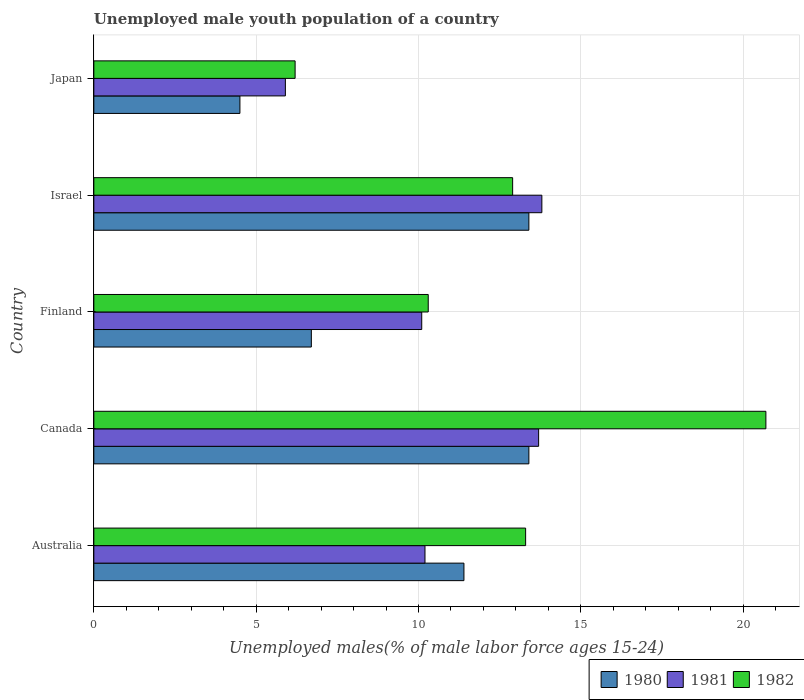Are the number of bars on each tick of the Y-axis equal?
Give a very brief answer. Yes. How many bars are there on the 5th tick from the top?
Your answer should be compact. 3. What is the label of the 5th group of bars from the top?
Make the answer very short. Australia. In how many cases, is the number of bars for a given country not equal to the number of legend labels?
Provide a short and direct response. 0. What is the percentage of unemployed male youth population in 1982 in Japan?
Your response must be concise. 6.2. Across all countries, what is the maximum percentage of unemployed male youth population in 1980?
Provide a succinct answer. 13.4. Across all countries, what is the minimum percentage of unemployed male youth population in 1982?
Make the answer very short. 6.2. In which country was the percentage of unemployed male youth population in 1980 maximum?
Your answer should be compact. Canada. What is the total percentage of unemployed male youth population in 1981 in the graph?
Provide a short and direct response. 53.7. What is the difference between the percentage of unemployed male youth population in 1981 in Finland and that in Israel?
Give a very brief answer. -3.7. What is the difference between the percentage of unemployed male youth population in 1981 in Japan and the percentage of unemployed male youth population in 1980 in Australia?
Your response must be concise. -5.5. What is the average percentage of unemployed male youth population in 1981 per country?
Provide a succinct answer. 10.74. What is the difference between the percentage of unemployed male youth population in 1981 and percentage of unemployed male youth population in 1982 in Israel?
Ensure brevity in your answer.  0.9. What is the ratio of the percentage of unemployed male youth population in 1981 in Australia to that in Canada?
Your answer should be very brief. 0.74. Is the difference between the percentage of unemployed male youth population in 1981 in Canada and Japan greater than the difference between the percentage of unemployed male youth population in 1982 in Canada and Japan?
Give a very brief answer. No. What is the difference between the highest and the second highest percentage of unemployed male youth population in 1981?
Give a very brief answer. 0.1. What is the difference between the highest and the lowest percentage of unemployed male youth population in 1982?
Your answer should be compact. 14.5. In how many countries, is the percentage of unemployed male youth population in 1982 greater than the average percentage of unemployed male youth population in 1982 taken over all countries?
Your answer should be very brief. 3. Is the sum of the percentage of unemployed male youth population in 1982 in Australia and Finland greater than the maximum percentage of unemployed male youth population in 1980 across all countries?
Your answer should be compact. Yes. What does the 2nd bar from the top in Japan represents?
Offer a terse response. 1981. How many bars are there?
Make the answer very short. 15. Are all the bars in the graph horizontal?
Ensure brevity in your answer.  Yes. Does the graph contain any zero values?
Offer a terse response. No. Does the graph contain grids?
Your response must be concise. Yes. What is the title of the graph?
Your response must be concise. Unemployed male youth population of a country. What is the label or title of the X-axis?
Your response must be concise. Unemployed males(% of male labor force ages 15-24). What is the Unemployed males(% of male labor force ages 15-24) in 1980 in Australia?
Your answer should be compact. 11.4. What is the Unemployed males(% of male labor force ages 15-24) in 1981 in Australia?
Make the answer very short. 10.2. What is the Unemployed males(% of male labor force ages 15-24) in 1982 in Australia?
Offer a very short reply. 13.3. What is the Unemployed males(% of male labor force ages 15-24) in 1980 in Canada?
Your answer should be compact. 13.4. What is the Unemployed males(% of male labor force ages 15-24) of 1981 in Canada?
Give a very brief answer. 13.7. What is the Unemployed males(% of male labor force ages 15-24) of 1982 in Canada?
Keep it short and to the point. 20.7. What is the Unemployed males(% of male labor force ages 15-24) in 1980 in Finland?
Keep it short and to the point. 6.7. What is the Unemployed males(% of male labor force ages 15-24) in 1981 in Finland?
Offer a terse response. 10.1. What is the Unemployed males(% of male labor force ages 15-24) in 1982 in Finland?
Offer a terse response. 10.3. What is the Unemployed males(% of male labor force ages 15-24) of 1980 in Israel?
Provide a succinct answer. 13.4. What is the Unemployed males(% of male labor force ages 15-24) in 1981 in Israel?
Your response must be concise. 13.8. What is the Unemployed males(% of male labor force ages 15-24) in 1982 in Israel?
Ensure brevity in your answer.  12.9. What is the Unemployed males(% of male labor force ages 15-24) in 1980 in Japan?
Offer a terse response. 4.5. What is the Unemployed males(% of male labor force ages 15-24) in 1981 in Japan?
Offer a very short reply. 5.9. What is the Unemployed males(% of male labor force ages 15-24) of 1982 in Japan?
Provide a succinct answer. 6.2. Across all countries, what is the maximum Unemployed males(% of male labor force ages 15-24) of 1980?
Give a very brief answer. 13.4. Across all countries, what is the maximum Unemployed males(% of male labor force ages 15-24) of 1981?
Keep it short and to the point. 13.8. Across all countries, what is the maximum Unemployed males(% of male labor force ages 15-24) in 1982?
Your answer should be compact. 20.7. Across all countries, what is the minimum Unemployed males(% of male labor force ages 15-24) in 1980?
Provide a succinct answer. 4.5. Across all countries, what is the minimum Unemployed males(% of male labor force ages 15-24) in 1981?
Offer a very short reply. 5.9. Across all countries, what is the minimum Unemployed males(% of male labor force ages 15-24) of 1982?
Provide a succinct answer. 6.2. What is the total Unemployed males(% of male labor force ages 15-24) in 1980 in the graph?
Your answer should be compact. 49.4. What is the total Unemployed males(% of male labor force ages 15-24) in 1981 in the graph?
Your answer should be very brief. 53.7. What is the total Unemployed males(% of male labor force ages 15-24) of 1982 in the graph?
Keep it short and to the point. 63.4. What is the difference between the Unemployed males(% of male labor force ages 15-24) of 1980 in Australia and that in Canada?
Your response must be concise. -2. What is the difference between the Unemployed males(% of male labor force ages 15-24) in 1981 in Australia and that in Canada?
Provide a short and direct response. -3.5. What is the difference between the Unemployed males(% of male labor force ages 15-24) in 1982 in Australia and that in Canada?
Offer a very short reply. -7.4. What is the difference between the Unemployed males(% of male labor force ages 15-24) in 1980 in Australia and that in Finland?
Your answer should be very brief. 4.7. What is the difference between the Unemployed males(% of male labor force ages 15-24) of 1981 in Australia and that in Finland?
Provide a short and direct response. 0.1. What is the difference between the Unemployed males(% of male labor force ages 15-24) in 1982 in Australia and that in Finland?
Keep it short and to the point. 3. What is the difference between the Unemployed males(% of male labor force ages 15-24) of 1981 in Australia and that in Israel?
Offer a terse response. -3.6. What is the difference between the Unemployed males(% of male labor force ages 15-24) of 1982 in Australia and that in Israel?
Keep it short and to the point. 0.4. What is the difference between the Unemployed males(% of male labor force ages 15-24) of 1980 in Australia and that in Japan?
Offer a very short reply. 6.9. What is the difference between the Unemployed males(% of male labor force ages 15-24) of 1981 in Australia and that in Japan?
Your answer should be very brief. 4.3. What is the difference between the Unemployed males(% of male labor force ages 15-24) of 1980 in Canada and that in Finland?
Offer a very short reply. 6.7. What is the difference between the Unemployed males(% of male labor force ages 15-24) in 1981 in Canada and that in Finland?
Make the answer very short. 3.6. What is the difference between the Unemployed males(% of male labor force ages 15-24) in 1980 in Canada and that in Israel?
Provide a succinct answer. 0. What is the difference between the Unemployed males(% of male labor force ages 15-24) of 1981 in Canada and that in Israel?
Ensure brevity in your answer.  -0.1. What is the difference between the Unemployed males(% of male labor force ages 15-24) of 1981 in Canada and that in Japan?
Your answer should be very brief. 7.8. What is the difference between the Unemployed males(% of male labor force ages 15-24) of 1982 in Canada and that in Japan?
Ensure brevity in your answer.  14.5. What is the difference between the Unemployed males(% of male labor force ages 15-24) in 1980 in Finland and that in Israel?
Provide a short and direct response. -6.7. What is the difference between the Unemployed males(% of male labor force ages 15-24) in 1981 in Finland and that in Israel?
Give a very brief answer. -3.7. What is the difference between the Unemployed males(% of male labor force ages 15-24) in 1982 in Finland and that in Israel?
Provide a succinct answer. -2.6. What is the difference between the Unemployed males(% of male labor force ages 15-24) in 1981 in Finland and that in Japan?
Make the answer very short. 4.2. What is the difference between the Unemployed males(% of male labor force ages 15-24) in 1982 in Finland and that in Japan?
Your answer should be very brief. 4.1. What is the difference between the Unemployed males(% of male labor force ages 15-24) of 1980 in Israel and that in Japan?
Make the answer very short. 8.9. What is the difference between the Unemployed males(% of male labor force ages 15-24) in 1981 in Israel and that in Japan?
Make the answer very short. 7.9. What is the difference between the Unemployed males(% of male labor force ages 15-24) in 1982 in Israel and that in Japan?
Provide a short and direct response. 6.7. What is the difference between the Unemployed males(% of male labor force ages 15-24) in 1980 in Australia and the Unemployed males(% of male labor force ages 15-24) in 1981 in Canada?
Offer a terse response. -2.3. What is the difference between the Unemployed males(% of male labor force ages 15-24) of 1980 in Australia and the Unemployed males(% of male labor force ages 15-24) of 1981 in Finland?
Offer a terse response. 1.3. What is the difference between the Unemployed males(% of male labor force ages 15-24) in 1980 in Australia and the Unemployed males(% of male labor force ages 15-24) in 1982 in Finland?
Keep it short and to the point. 1.1. What is the difference between the Unemployed males(% of male labor force ages 15-24) of 1981 in Australia and the Unemployed males(% of male labor force ages 15-24) of 1982 in Finland?
Provide a short and direct response. -0.1. What is the difference between the Unemployed males(% of male labor force ages 15-24) of 1980 in Australia and the Unemployed males(% of male labor force ages 15-24) of 1981 in Israel?
Ensure brevity in your answer.  -2.4. What is the difference between the Unemployed males(% of male labor force ages 15-24) of 1980 in Australia and the Unemployed males(% of male labor force ages 15-24) of 1982 in Israel?
Your response must be concise. -1.5. What is the difference between the Unemployed males(% of male labor force ages 15-24) in 1981 in Australia and the Unemployed males(% of male labor force ages 15-24) in 1982 in Israel?
Make the answer very short. -2.7. What is the difference between the Unemployed males(% of male labor force ages 15-24) in 1980 in Australia and the Unemployed males(% of male labor force ages 15-24) in 1981 in Japan?
Make the answer very short. 5.5. What is the difference between the Unemployed males(% of male labor force ages 15-24) of 1980 in Australia and the Unemployed males(% of male labor force ages 15-24) of 1982 in Japan?
Offer a very short reply. 5.2. What is the difference between the Unemployed males(% of male labor force ages 15-24) of 1980 in Canada and the Unemployed males(% of male labor force ages 15-24) of 1982 in Finland?
Your answer should be compact. 3.1. What is the difference between the Unemployed males(% of male labor force ages 15-24) in 1981 in Canada and the Unemployed males(% of male labor force ages 15-24) in 1982 in Israel?
Your answer should be compact. 0.8. What is the difference between the Unemployed males(% of male labor force ages 15-24) in 1980 in Finland and the Unemployed males(% of male labor force ages 15-24) in 1981 in Israel?
Provide a short and direct response. -7.1. What is the difference between the Unemployed males(% of male labor force ages 15-24) in 1980 in Finland and the Unemployed males(% of male labor force ages 15-24) in 1982 in Israel?
Make the answer very short. -6.2. What is the difference between the Unemployed males(% of male labor force ages 15-24) in 1981 in Finland and the Unemployed males(% of male labor force ages 15-24) in 1982 in Israel?
Your answer should be compact. -2.8. What is the difference between the Unemployed males(% of male labor force ages 15-24) of 1980 in Finland and the Unemployed males(% of male labor force ages 15-24) of 1981 in Japan?
Offer a very short reply. 0.8. What is the difference between the Unemployed males(% of male labor force ages 15-24) of 1980 in Finland and the Unemployed males(% of male labor force ages 15-24) of 1982 in Japan?
Keep it short and to the point. 0.5. What is the difference between the Unemployed males(% of male labor force ages 15-24) of 1981 in Finland and the Unemployed males(% of male labor force ages 15-24) of 1982 in Japan?
Ensure brevity in your answer.  3.9. What is the difference between the Unemployed males(% of male labor force ages 15-24) in 1980 in Israel and the Unemployed males(% of male labor force ages 15-24) in 1981 in Japan?
Offer a very short reply. 7.5. What is the difference between the Unemployed males(% of male labor force ages 15-24) in 1981 in Israel and the Unemployed males(% of male labor force ages 15-24) in 1982 in Japan?
Keep it short and to the point. 7.6. What is the average Unemployed males(% of male labor force ages 15-24) in 1980 per country?
Provide a short and direct response. 9.88. What is the average Unemployed males(% of male labor force ages 15-24) of 1981 per country?
Your response must be concise. 10.74. What is the average Unemployed males(% of male labor force ages 15-24) in 1982 per country?
Your response must be concise. 12.68. What is the difference between the Unemployed males(% of male labor force ages 15-24) in 1981 and Unemployed males(% of male labor force ages 15-24) in 1982 in Australia?
Offer a terse response. -3.1. What is the difference between the Unemployed males(% of male labor force ages 15-24) in 1980 and Unemployed males(% of male labor force ages 15-24) in 1981 in Canada?
Offer a terse response. -0.3. What is the difference between the Unemployed males(% of male labor force ages 15-24) of 1980 and Unemployed males(% of male labor force ages 15-24) of 1982 in Canada?
Your answer should be very brief. -7.3. What is the difference between the Unemployed males(% of male labor force ages 15-24) of 1980 and Unemployed males(% of male labor force ages 15-24) of 1981 in Finland?
Offer a very short reply. -3.4. What is the difference between the Unemployed males(% of male labor force ages 15-24) in 1980 and Unemployed males(% of male labor force ages 15-24) in 1982 in Finland?
Make the answer very short. -3.6. What is the difference between the Unemployed males(% of male labor force ages 15-24) of 1981 and Unemployed males(% of male labor force ages 15-24) of 1982 in Israel?
Keep it short and to the point. 0.9. What is the difference between the Unemployed males(% of male labor force ages 15-24) of 1980 and Unemployed males(% of male labor force ages 15-24) of 1981 in Japan?
Make the answer very short. -1.4. What is the ratio of the Unemployed males(% of male labor force ages 15-24) of 1980 in Australia to that in Canada?
Give a very brief answer. 0.85. What is the ratio of the Unemployed males(% of male labor force ages 15-24) in 1981 in Australia to that in Canada?
Make the answer very short. 0.74. What is the ratio of the Unemployed males(% of male labor force ages 15-24) in 1982 in Australia to that in Canada?
Give a very brief answer. 0.64. What is the ratio of the Unemployed males(% of male labor force ages 15-24) of 1980 in Australia to that in Finland?
Ensure brevity in your answer.  1.7. What is the ratio of the Unemployed males(% of male labor force ages 15-24) in 1981 in Australia to that in Finland?
Provide a succinct answer. 1.01. What is the ratio of the Unemployed males(% of male labor force ages 15-24) in 1982 in Australia to that in Finland?
Your answer should be compact. 1.29. What is the ratio of the Unemployed males(% of male labor force ages 15-24) in 1980 in Australia to that in Israel?
Provide a succinct answer. 0.85. What is the ratio of the Unemployed males(% of male labor force ages 15-24) of 1981 in Australia to that in Israel?
Give a very brief answer. 0.74. What is the ratio of the Unemployed males(% of male labor force ages 15-24) of 1982 in Australia to that in Israel?
Provide a succinct answer. 1.03. What is the ratio of the Unemployed males(% of male labor force ages 15-24) of 1980 in Australia to that in Japan?
Your response must be concise. 2.53. What is the ratio of the Unemployed males(% of male labor force ages 15-24) of 1981 in Australia to that in Japan?
Provide a short and direct response. 1.73. What is the ratio of the Unemployed males(% of male labor force ages 15-24) in 1982 in Australia to that in Japan?
Your response must be concise. 2.15. What is the ratio of the Unemployed males(% of male labor force ages 15-24) in 1980 in Canada to that in Finland?
Provide a succinct answer. 2. What is the ratio of the Unemployed males(% of male labor force ages 15-24) of 1981 in Canada to that in Finland?
Your answer should be compact. 1.36. What is the ratio of the Unemployed males(% of male labor force ages 15-24) of 1982 in Canada to that in Finland?
Your answer should be very brief. 2.01. What is the ratio of the Unemployed males(% of male labor force ages 15-24) of 1982 in Canada to that in Israel?
Keep it short and to the point. 1.6. What is the ratio of the Unemployed males(% of male labor force ages 15-24) in 1980 in Canada to that in Japan?
Make the answer very short. 2.98. What is the ratio of the Unemployed males(% of male labor force ages 15-24) in 1981 in Canada to that in Japan?
Make the answer very short. 2.32. What is the ratio of the Unemployed males(% of male labor force ages 15-24) in 1982 in Canada to that in Japan?
Your answer should be compact. 3.34. What is the ratio of the Unemployed males(% of male labor force ages 15-24) of 1980 in Finland to that in Israel?
Provide a short and direct response. 0.5. What is the ratio of the Unemployed males(% of male labor force ages 15-24) of 1981 in Finland to that in Israel?
Make the answer very short. 0.73. What is the ratio of the Unemployed males(% of male labor force ages 15-24) in 1982 in Finland to that in Israel?
Keep it short and to the point. 0.8. What is the ratio of the Unemployed males(% of male labor force ages 15-24) in 1980 in Finland to that in Japan?
Ensure brevity in your answer.  1.49. What is the ratio of the Unemployed males(% of male labor force ages 15-24) in 1981 in Finland to that in Japan?
Make the answer very short. 1.71. What is the ratio of the Unemployed males(% of male labor force ages 15-24) in 1982 in Finland to that in Japan?
Your answer should be compact. 1.66. What is the ratio of the Unemployed males(% of male labor force ages 15-24) of 1980 in Israel to that in Japan?
Offer a terse response. 2.98. What is the ratio of the Unemployed males(% of male labor force ages 15-24) in 1981 in Israel to that in Japan?
Give a very brief answer. 2.34. What is the ratio of the Unemployed males(% of male labor force ages 15-24) in 1982 in Israel to that in Japan?
Your answer should be compact. 2.08. What is the difference between the highest and the second highest Unemployed males(% of male labor force ages 15-24) of 1980?
Make the answer very short. 0. What is the difference between the highest and the lowest Unemployed males(% of male labor force ages 15-24) of 1980?
Offer a very short reply. 8.9. What is the difference between the highest and the lowest Unemployed males(% of male labor force ages 15-24) of 1981?
Offer a very short reply. 7.9. 